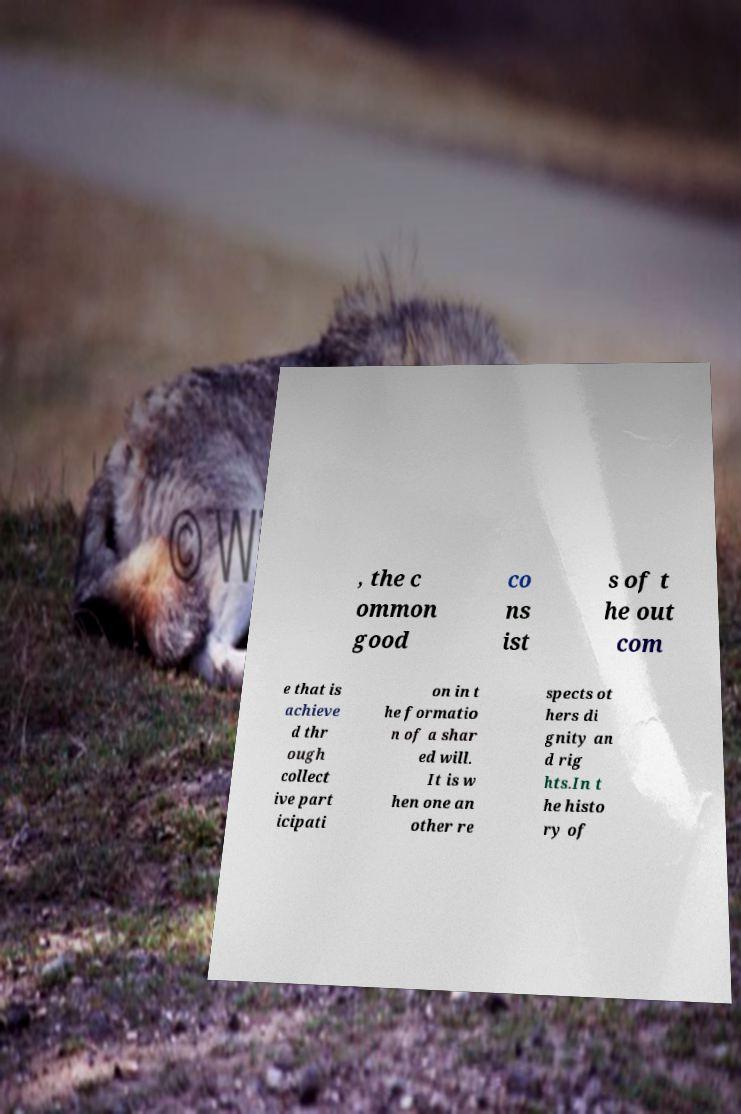What messages or text are displayed in this image? I need them in a readable, typed format. , the c ommon good co ns ist s of t he out com e that is achieve d thr ough collect ive part icipati on in t he formatio n of a shar ed will. It is w hen one an other re spects ot hers di gnity an d rig hts.In t he histo ry of 